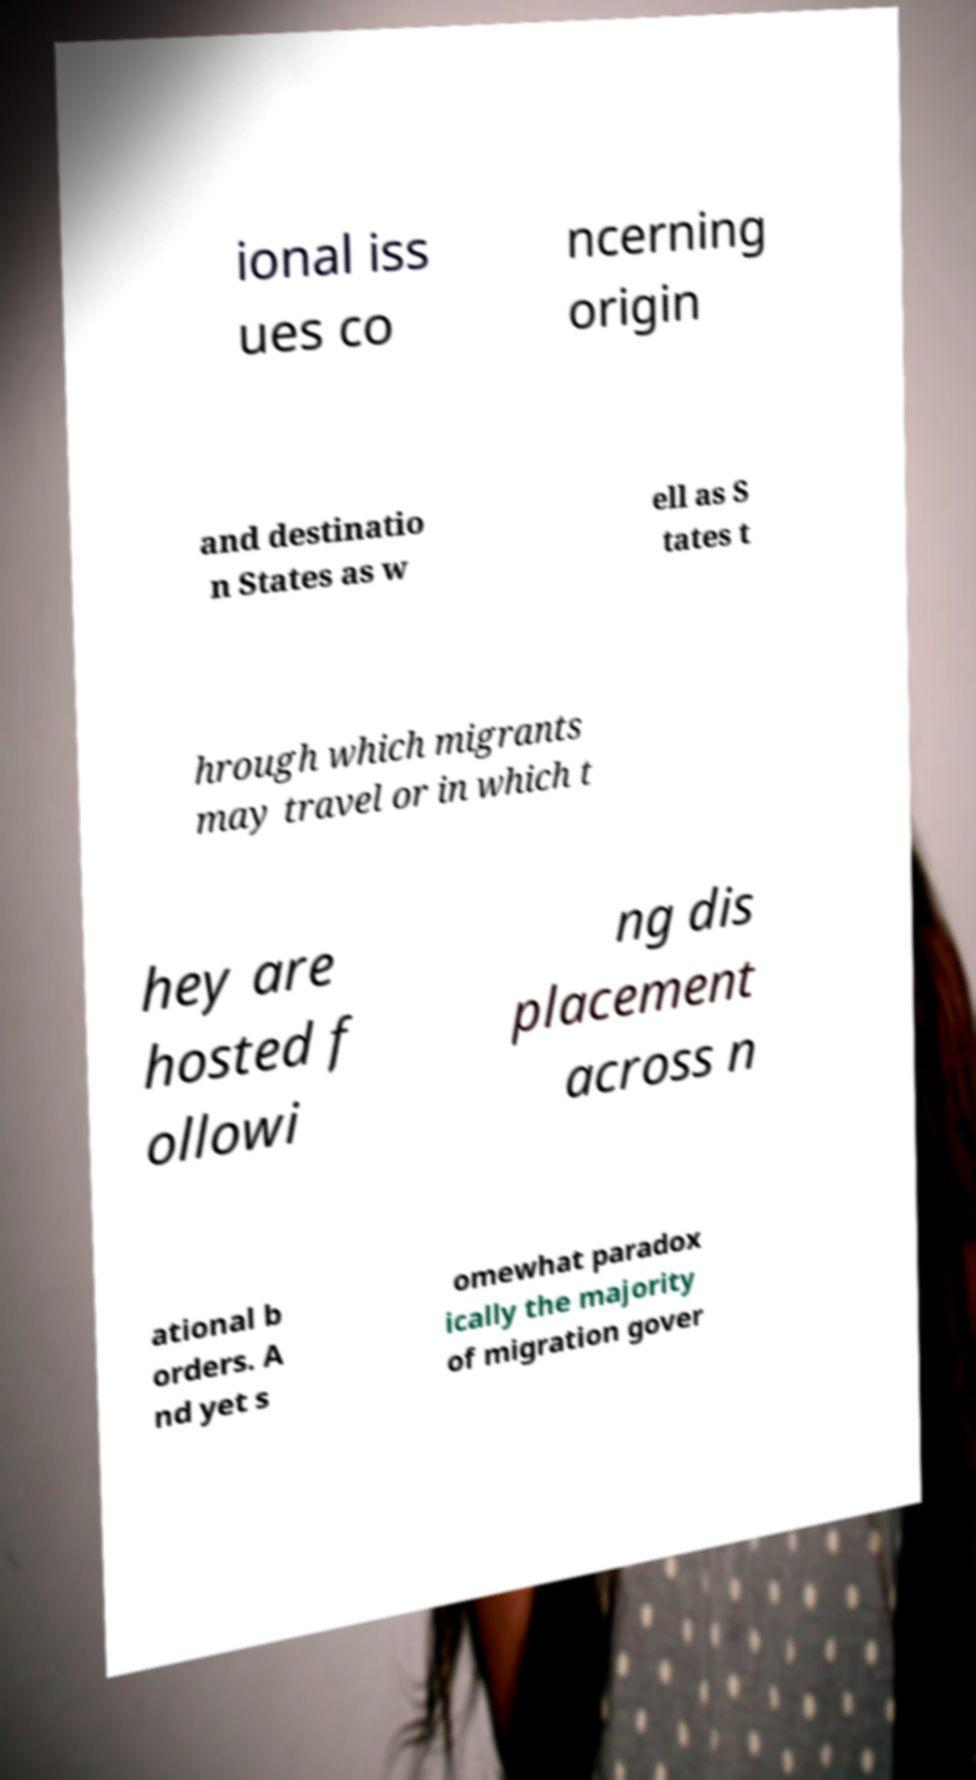Could you extract and type out the text from this image? ional iss ues co ncerning origin and destinatio n States as w ell as S tates t hrough which migrants may travel or in which t hey are hosted f ollowi ng dis placement across n ational b orders. A nd yet s omewhat paradox ically the majority of migration gover 